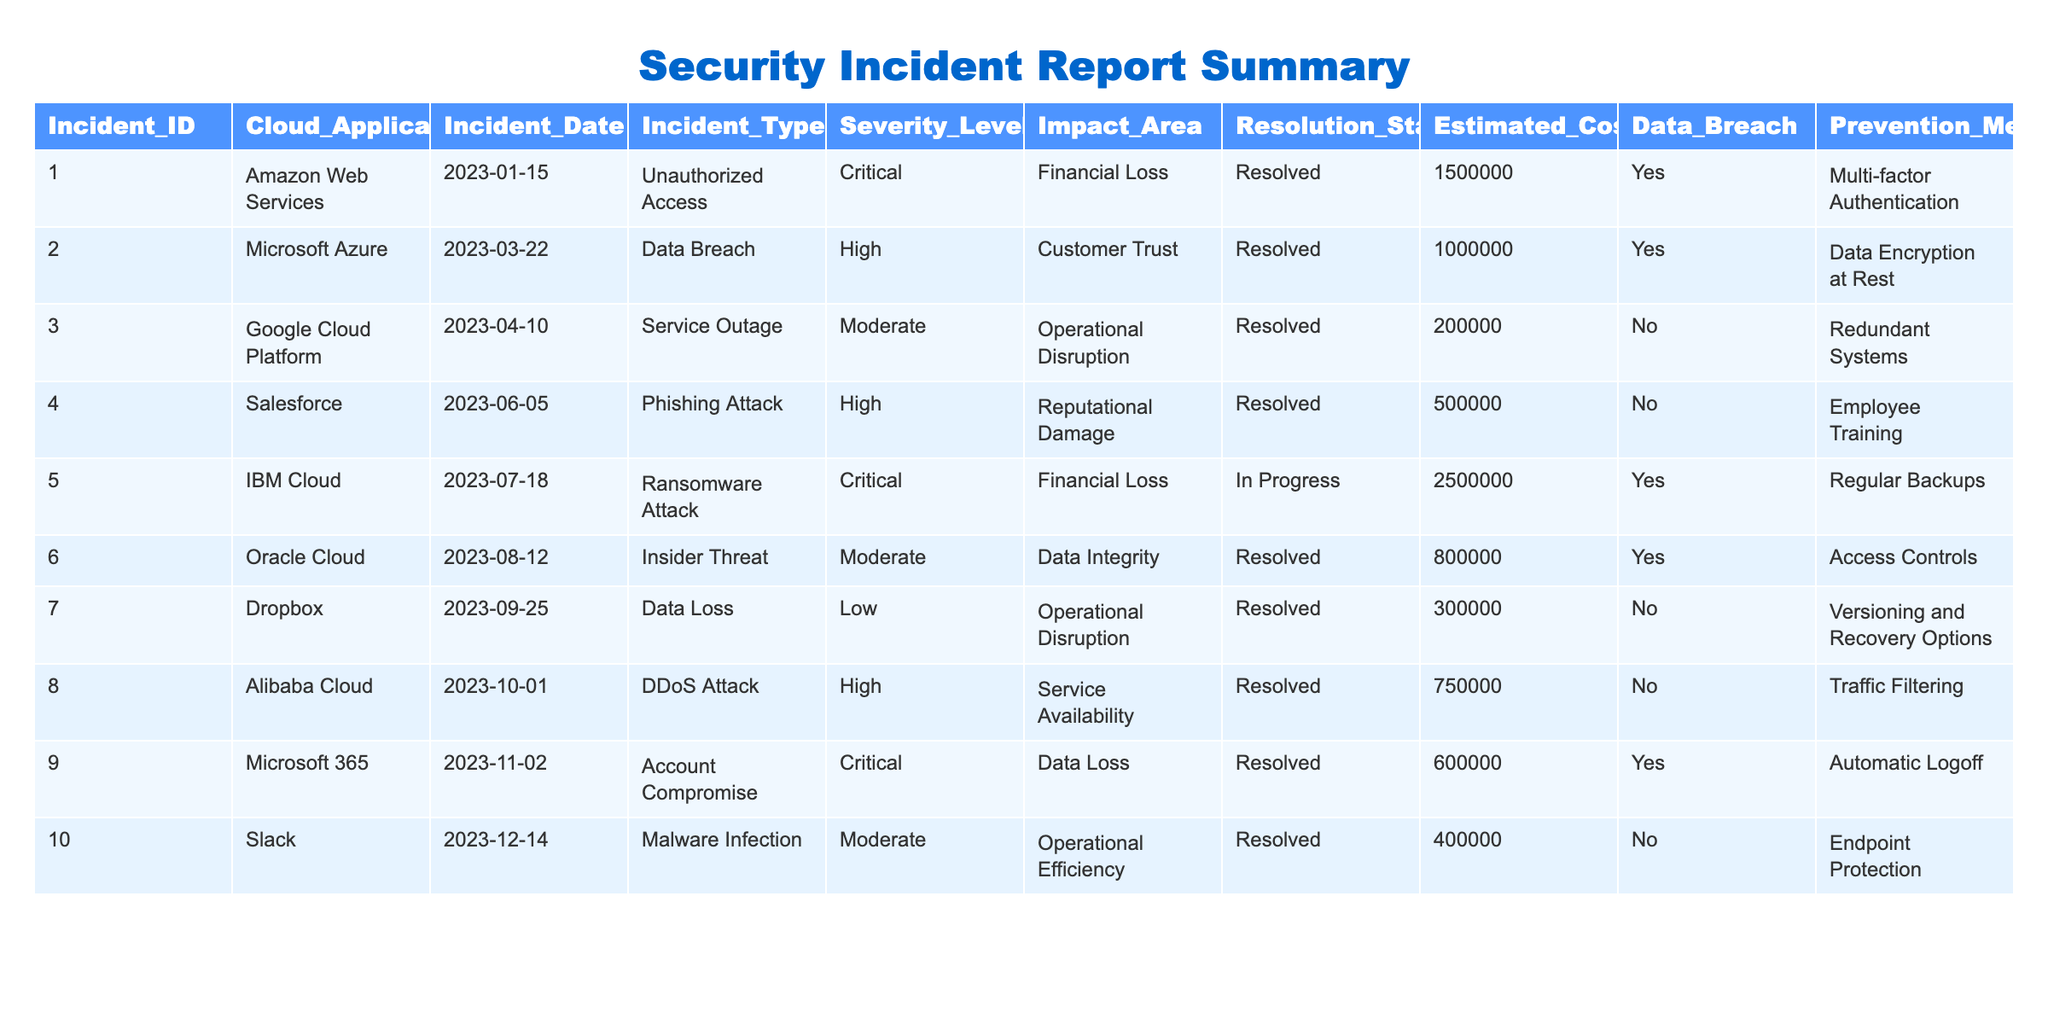What is the total estimated cost of all incidents reported? By summing the estimated costs of all the incidents: 1,500,000 + 1,000,000 + 200,000 + 500,000 + 2,500,000 + 800,000 + 300,000 + 750,000 + 600,000 + 400,000 = 8,100,000.
Answer: 8,100,000 How many incidents resulted in a data breach? There are four incidents where the data breach status is marked as "Yes": Incident ID 1, 2, 5, and 6.
Answer: 4 Which cloud application had the highest estimated cost for an incident? The incident with the highest estimated cost is the one from IBM Cloud with an estimated cost of 2,500,000.
Answer: IBM Cloud What severity level is associated with the most incidents? The severity levels are counted: Critical (3), High (4), Moderate (3), and Low (1). The highest frequency is High, with 4 incidents.
Answer: High Are there any unresolved incidents in the report? Only one incident is marked as "In Progress," which indicates it is unresolved.
Answer: Yes What is the average estimated cost for incidents classified as Critical? There are three Critical incidents with estimated costs of: 1,500,000 (AWS), 2,500,000 (IBM), and 600,000 (Microsoft 365). The average is (1,500,000 + 2,500,000 + 600,000)/3 = 1,533,333.
Answer: 1,533,333 How many incidents had an impact on customer trust? Two incidents are directly related to customer trust: Microsoft Azure (Data Breach) and Salesforce (Phishing Attack).
Answer: 2 Which prevention measure was used for the most recent incident reported? The most recent incident reported is from Slack with a prevention measure of "Endpoint Protection."
Answer: Endpoint Protection Is there any incident where the resolution status is "Resolved" but still had a significant impact on financial loss? Yes, there are two incidents categorized as "Resolved" that resulted in financial loss: AWS and Salesforce.
Answer: Yes Which type of incident posed the greatest risk in terms of severity level and impact area? The incident categorized as "Unauthorized Access" on AWS, labeled Critical and causing financial loss, represents the highest risk.
Answer: Unauthorized Access on AWS 